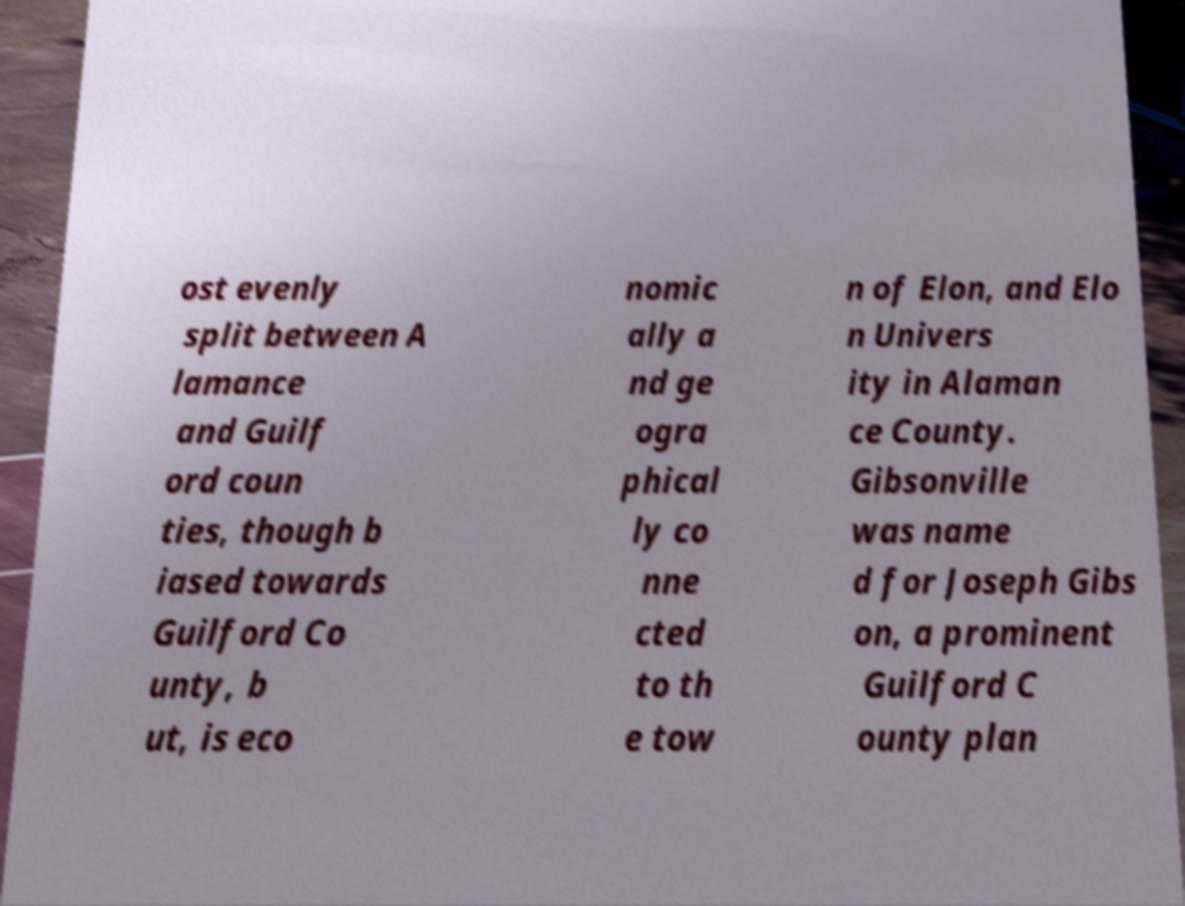Please read and relay the text visible in this image. What does it say? ost evenly split between A lamance and Guilf ord coun ties, though b iased towards Guilford Co unty, b ut, is eco nomic ally a nd ge ogra phical ly co nne cted to th e tow n of Elon, and Elo n Univers ity in Alaman ce County. Gibsonville was name d for Joseph Gibs on, a prominent Guilford C ounty plan 